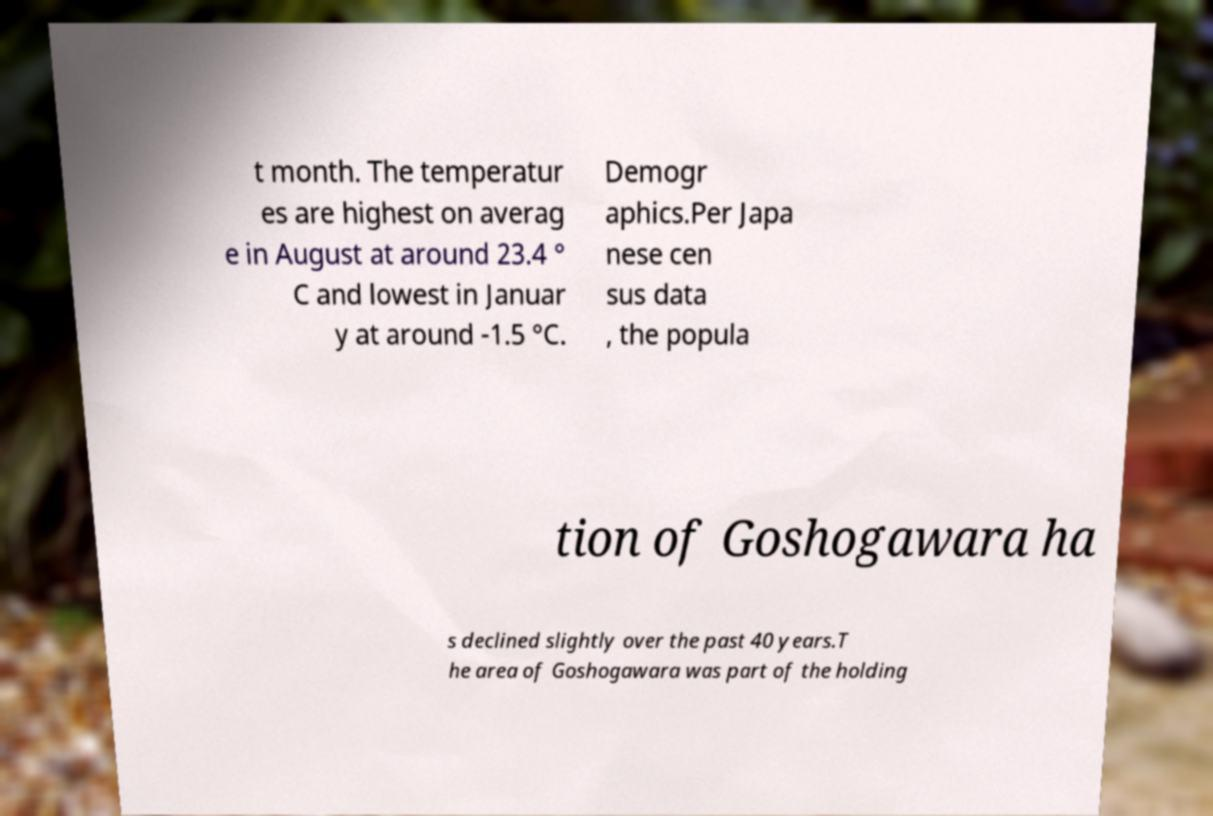For documentation purposes, I need the text within this image transcribed. Could you provide that? t month. The temperatur es are highest on averag e in August at around 23.4 ° C and lowest in Januar y at around -1.5 °C. Demogr aphics.Per Japa nese cen sus data , the popula tion of Goshogawara ha s declined slightly over the past 40 years.T he area of Goshogawara was part of the holding 